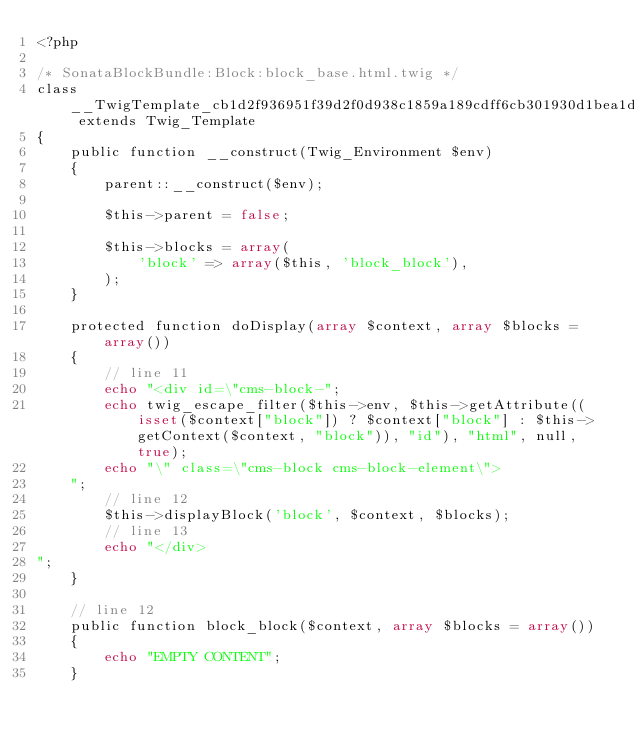<code> <loc_0><loc_0><loc_500><loc_500><_PHP_><?php

/* SonataBlockBundle:Block:block_base.html.twig */
class __TwigTemplate_cb1d2f936951f39d2f0d938c1859a189cdff6cb301930d1bea1ddbeab1bb0abf extends Twig_Template
{
    public function __construct(Twig_Environment $env)
    {
        parent::__construct($env);

        $this->parent = false;

        $this->blocks = array(
            'block' => array($this, 'block_block'),
        );
    }

    protected function doDisplay(array $context, array $blocks = array())
    {
        // line 11
        echo "<div id=\"cms-block-";
        echo twig_escape_filter($this->env, $this->getAttribute((isset($context["block"]) ? $context["block"] : $this->getContext($context, "block")), "id"), "html", null, true);
        echo "\" class=\"cms-block cms-block-element\">
    ";
        // line 12
        $this->displayBlock('block', $context, $blocks);
        // line 13
        echo "</div>
";
    }

    // line 12
    public function block_block($context, array $blocks = array())
    {
        echo "EMPTY CONTENT";
    }
</code> 